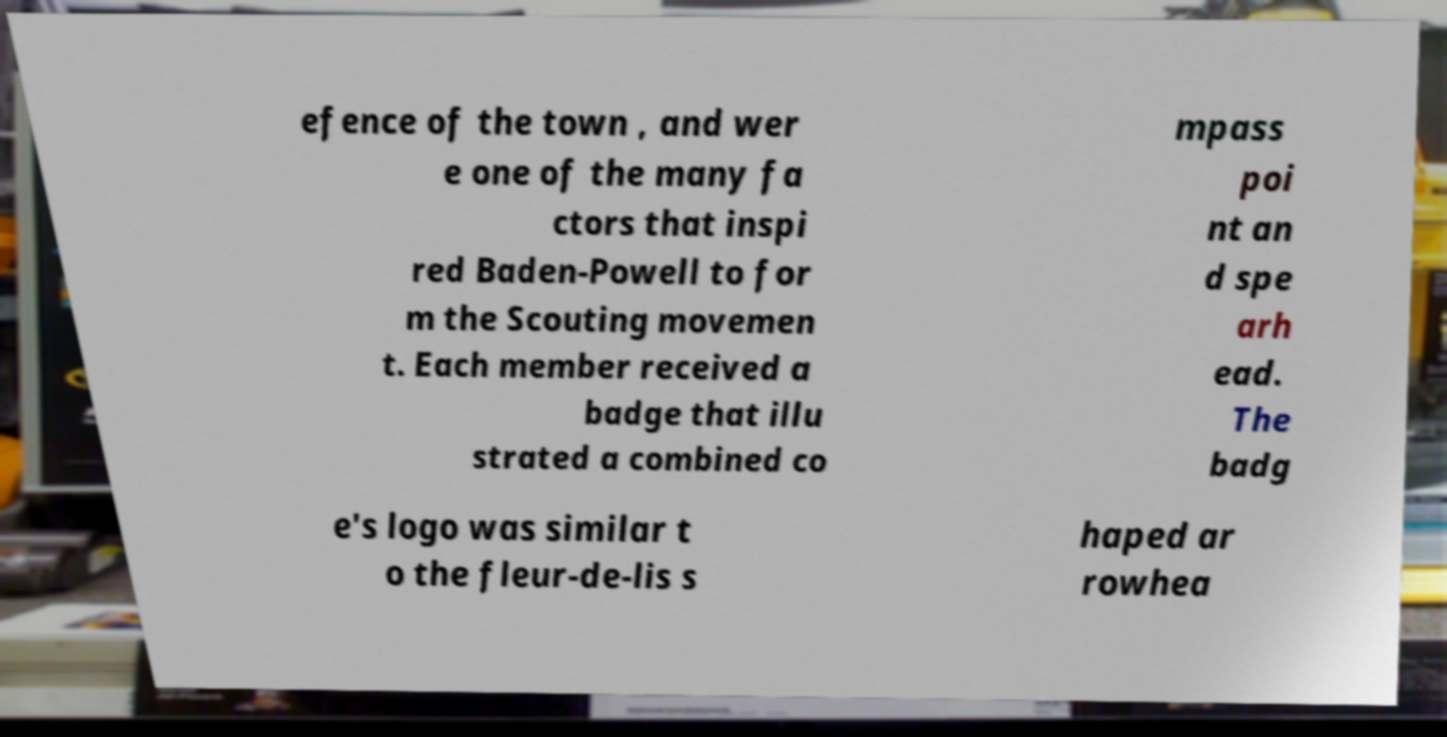Please read and relay the text visible in this image. What does it say? efence of the town , and wer e one of the many fa ctors that inspi red Baden-Powell to for m the Scouting movemen t. Each member received a badge that illu strated a combined co mpass poi nt an d spe arh ead. The badg e's logo was similar t o the fleur-de-lis s haped ar rowhea 